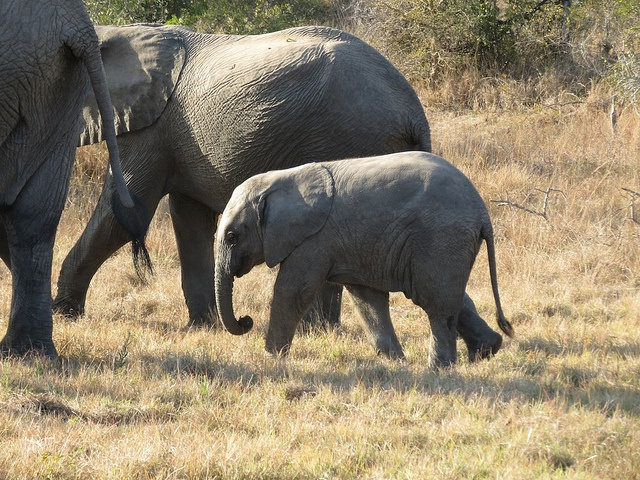Describe the objects in this image and their specific colors. I can see elephant in purple, black, gray, beige, and darkgray tones, elephant in purple, black, gray, darkgray, and ivory tones, and elephant in purple, black, and gray tones in this image. 